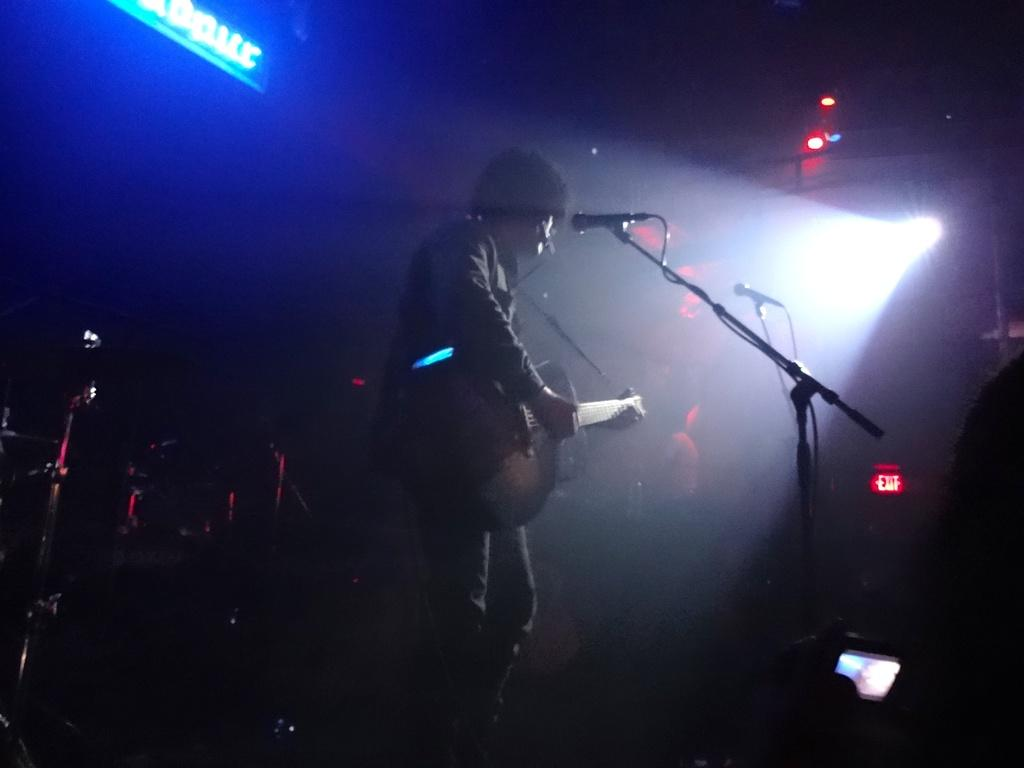What is the person in the image doing? The person is holding a guitar and standing in front of a microphone. What can be seen in the background of the image? There are stage lights in the background of the image. How would you describe the lighting in the image? The image is slightly dark. What type of pain is the person experiencing in the image? There is no indication of pain in the image; the person is holding a guitar and standing in front of a microphone. 